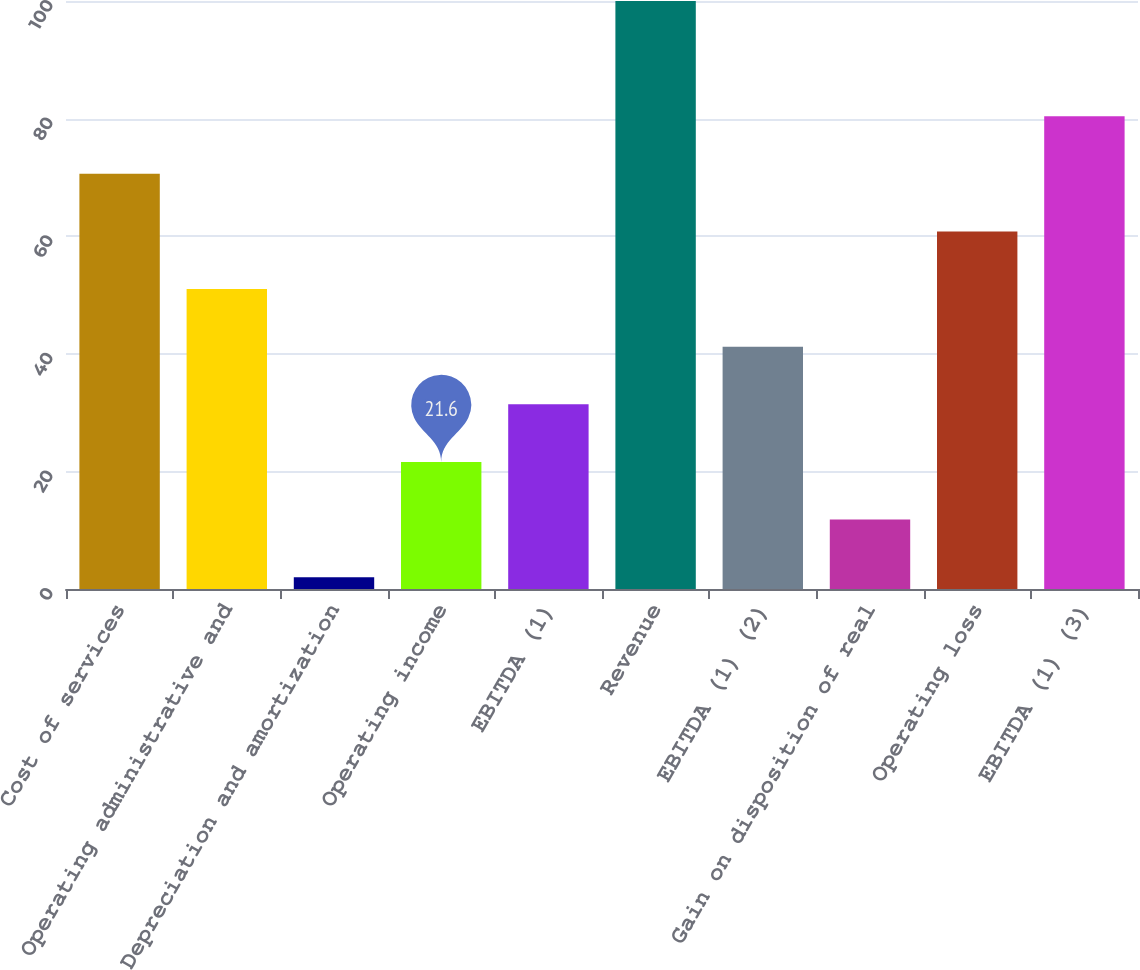Convert chart to OTSL. <chart><loc_0><loc_0><loc_500><loc_500><bar_chart><fcel>Cost of services<fcel>Operating administrative and<fcel>Depreciation and amortization<fcel>Operating income<fcel>EBITDA (1)<fcel>Revenue<fcel>EBITDA (1) (2)<fcel>Gain on disposition of real<fcel>Operating loss<fcel>EBITDA (1) (3)<nl><fcel>70.6<fcel>51<fcel>2<fcel>21.6<fcel>31.4<fcel>100<fcel>41.2<fcel>11.8<fcel>60.8<fcel>80.4<nl></chart> 